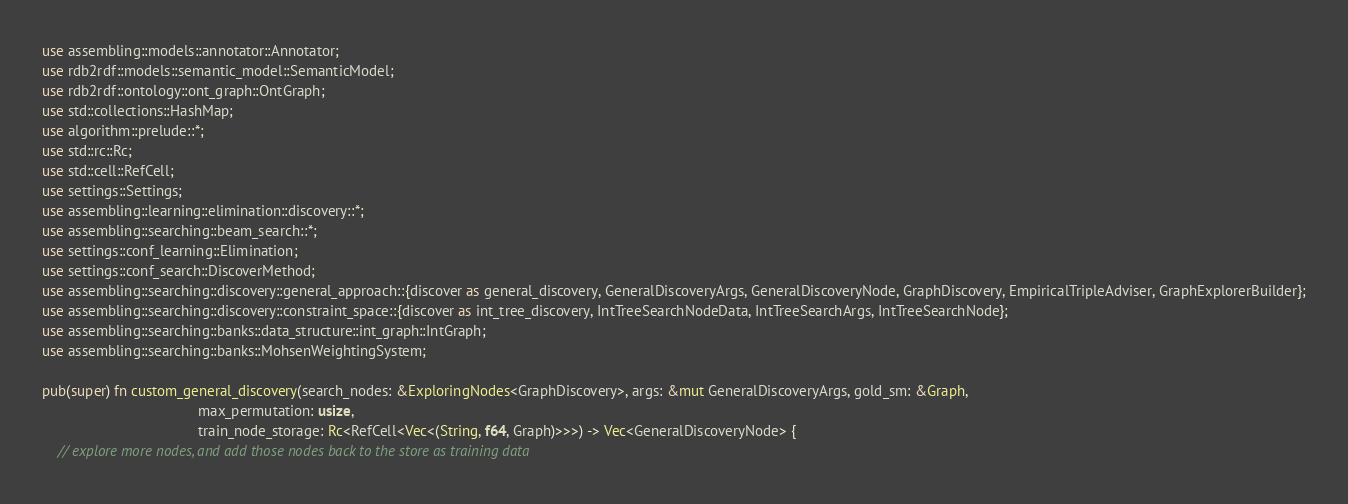Convert code to text. <code><loc_0><loc_0><loc_500><loc_500><_Rust_>use assembling::models::annotator::Annotator;
use rdb2rdf::models::semantic_model::SemanticModel;
use rdb2rdf::ontology::ont_graph::OntGraph;
use std::collections::HashMap;
use algorithm::prelude::*;
use std::rc::Rc;
use std::cell::RefCell;
use settings::Settings;
use assembling::learning::elimination::discovery::*;
use assembling::searching::beam_search::*;
use settings::conf_learning::Elimination;
use settings::conf_search::DiscoverMethod;
use assembling::searching::discovery::general_approach::{discover as general_discovery, GeneralDiscoveryArgs, GeneralDiscoveryNode, GraphDiscovery, EmpiricalTripleAdviser, GraphExplorerBuilder};
use assembling::searching::discovery::constraint_space::{discover as int_tree_discovery, IntTreeSearchNodeData, IntTreeSearchArgs, IntTreeSearchNode};
use assembling::searching::banks::data_structure::int_graph::IntGraph;
use assembling::searching::banks::MohsenWeightingSystem;

pub(super) fn custom_general_discovery(search_nodes: &ExploringNodes<GraphDiscovery>, args: &mut GeneralDiscoveryArgs, gold_sm: &Graph,
                                       max_permutation: usize,
                                       train_node_storage: Rc<RefCell<Vec<(String, f64, Graph)>>>) -> Vec<GeneralDiscoveryNode> {
    // explore more nodes, and add those nodes back to the store as training data</code> 